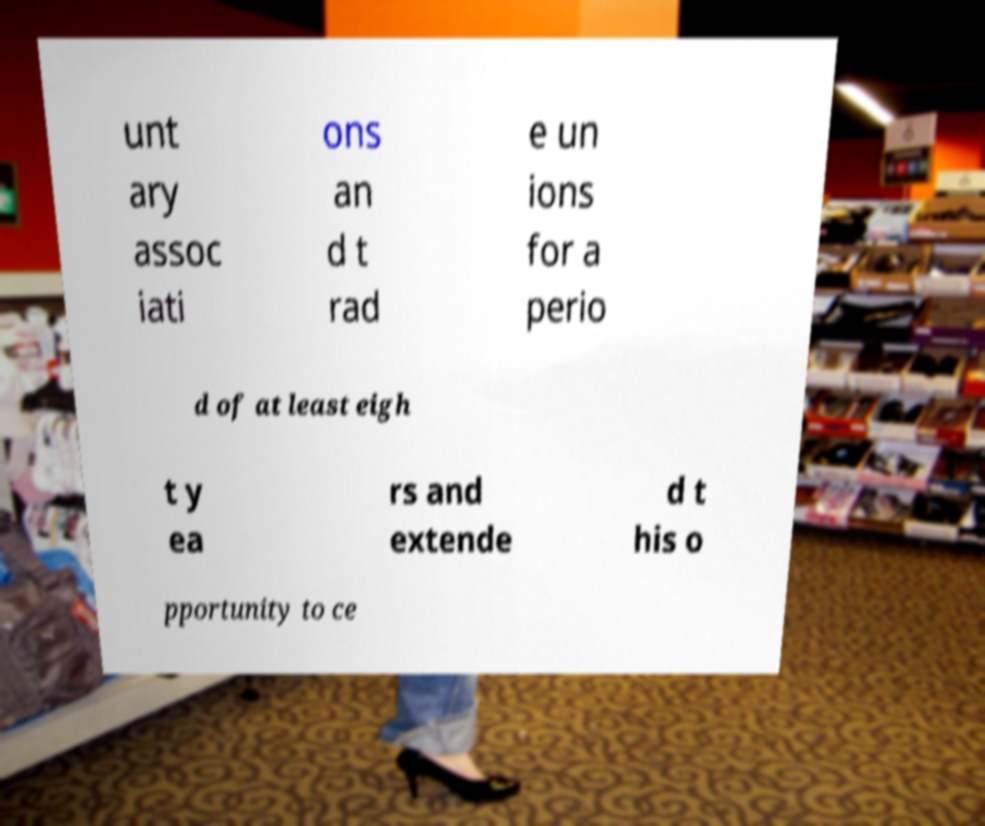Please read and relay the text visible in this image. What does it say? unt ary assoc iati ons an d t rad e un ions for a perio d of at least eigh t y ea rs and extende d t his o pportunity to ce 